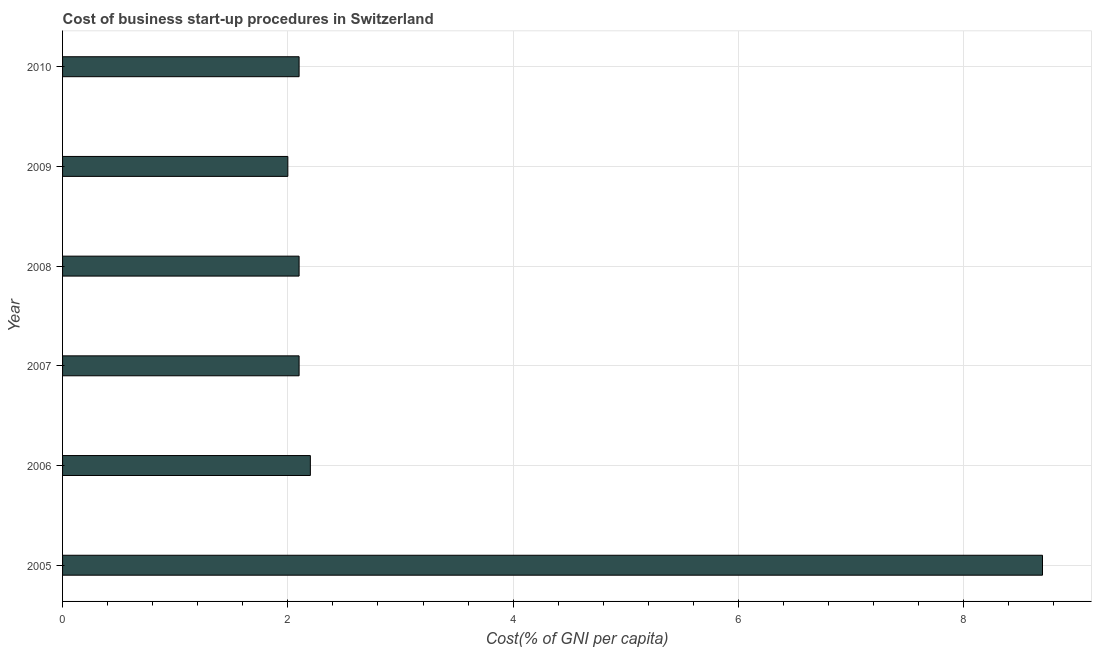What is the title of the graph?
Your response must be concise. Cost of business start-up procedures in Switzerland. What is the label or title of the X-axis?
Offer a very short reply. Cost(% of GNI per capita). What is the label or title of the Y-axis?
Ensure brevity in your answer.  Year. Across all years, what is the maximum cost of business startup procedures?
Your answer should be very brief. 8.7. What is the sum of the cost of business startup procedures?
Offer a terse response. 19.2. What is the difference between the cost of business startup procedures in 2005 and 2007?
Offer a very short reply. 6.6. What is the average cost of business startup procedures per year?
Your answer should be very brief. 3.2. What is the median cost of business startup procedures?
Offer a terse response. 2.1. Do a majority of the years between 2008 and 2005 (inclusive) have cost of business startup procedures greater than 2.8 %?
Your answer should be very brief. Yes. What is the ratio of the cost of business startup procedures in 2007 to that in 2008?
Keep it short and to the point. 1. Is the difference between the cost of business startup procedures in 2005 and 2007 greater than the difference between any two years?
Offer a terse response. No. Are all the bars in the graph horizontal?
Provide a short and direct response. Yes. What is the Cost(% of GNI per capita) in 2005?
Your answer should be compact. 8.7. What is the Cost(% of GNI per capita) in 2006?
Your response must be concise. 2.2. What is the Cost(% of GNI per capita) of 2007?
Your answer should be compact. 2.1. What is the Cost(% of GNI per capita) in 2009?
Make the answer very short. 2. What is the Cost(% of GNI per capita) in 2010?
Provide a succinct answer. 2.1. What is the difference between the Cost(% of GNI per capita) in 2005 and 2006?
Provide a succinct answer. 6.5. What is the difference between the Cost(% of GNI per capita) in 2006 and 2008?
Keep it short and to the point. 0.1. What is the difference between the Cost(% of GNI per capita) in 2007 and 2008?
Give a very brief answer. 0. What is the difference between the Cost(% of GNI per capita) in 2007 and 2009?
Keep it short and to the point. 0.1. What is the difference between the Cost(% of GNI per capita) in 2008 and 2009?
Your answer should be very brief. 0.1. What is the difference between the Cost(% of GNI per capita) in 2008 and 2010?
Offer a terse response. 0. What is the ratio of the Cost(% of GNI per capita) in 2005 to that in 2006?
Keep it short and to the point. 3.96. What is the ratio of the Cost(% of GNI per capita) in 2005 to that in 2007?
Your answer should be very brief. 4.14. What is the ratio of the Cost(% of GNI per capita) in 2005 to that in 2008?
Your answer should be compact. 4.14. What is the ratio of the Cost(% of GNI per capita) in 2005 to that in 2009?
Your answer should be compact. 4.35. What is the ratio of the Cost(% of GNI per capita) in 2005 to that in 2010?
Your response must be concise. 4.14. What is the ratio of the Cost(% of GNI per capita) in 2006 to that in 2007?
Give a very brief answer. 1.05. What is the ratio of the Cost(% of GNI per capita) in 2006 to that in 2008?
Ensure brevity in your answer.  1.05. What is the ratio of the Cost(% of GNI per capita) in 2006 to that in 2010?
Provide a short and direct response. 1.05. What is the ratio of the Cost(% of GNI per capita) in 2007 to that in 2008?
Offer a terse response. 1. What is the ratio of the Cost(% of GNI per capita) in 2007 to that in 2010?
Give a very brief answer. 1. What is the ratio of the Cost(% of GNI per capita) in 2008 to that in 2009?
Your answer should be compact. 1.05. What is the ratio of the Cost(% of GNI per capita) in 2008 to that in 2010?
Your answer should be compact. 1. 